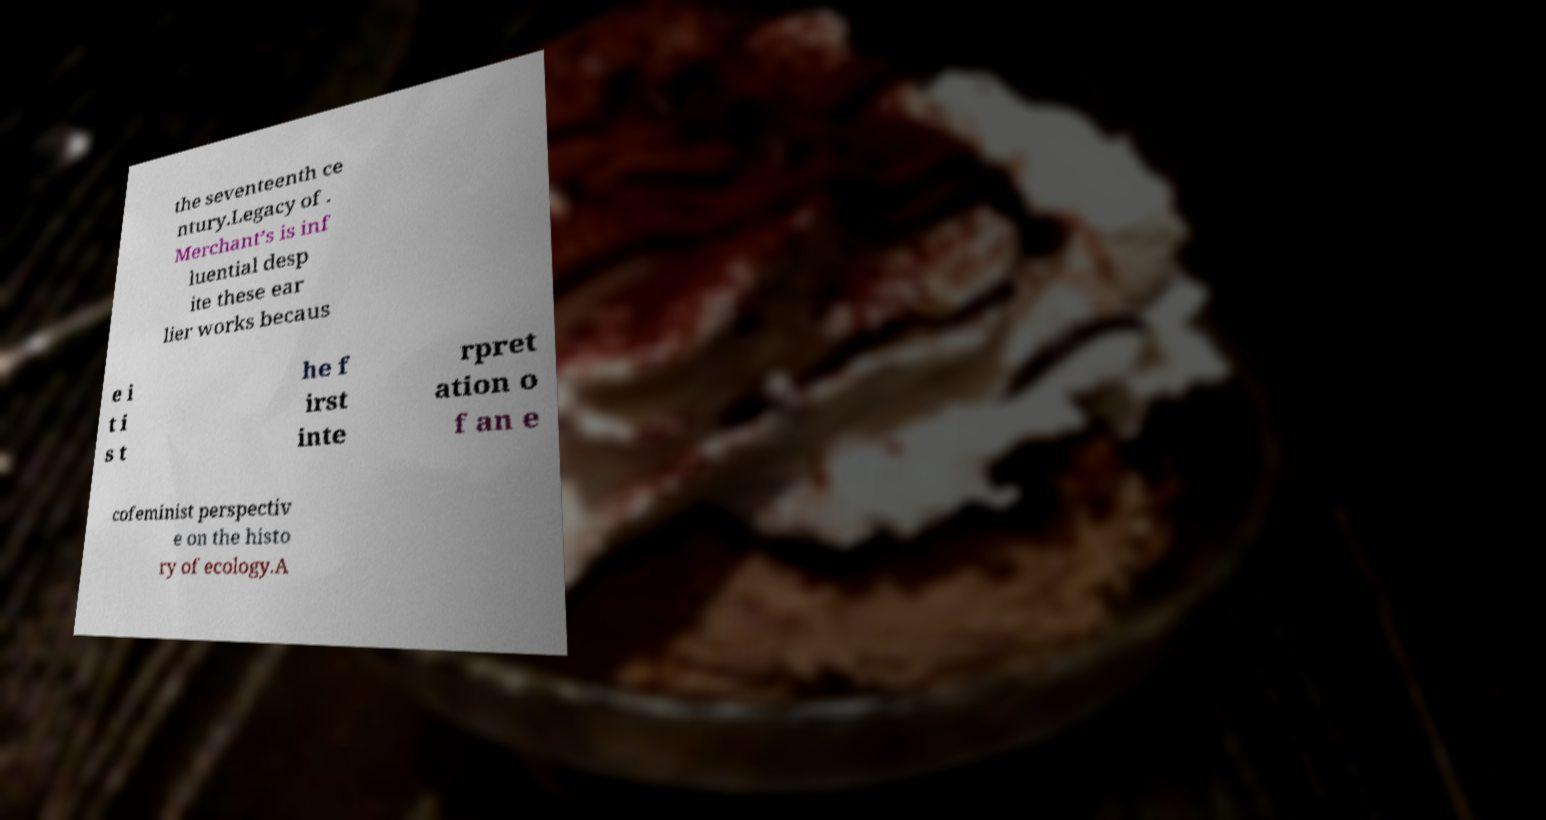Please read and relay the text visible in this image. What does it say? the seventeenth ce ntury.Legacy of . Merchant’s is inf luential desp ite these ear lier works becaus e i t i s t he f irst inte rpret ation o f an e cofeminist perspectiv e on the histo ry of ecology.A 